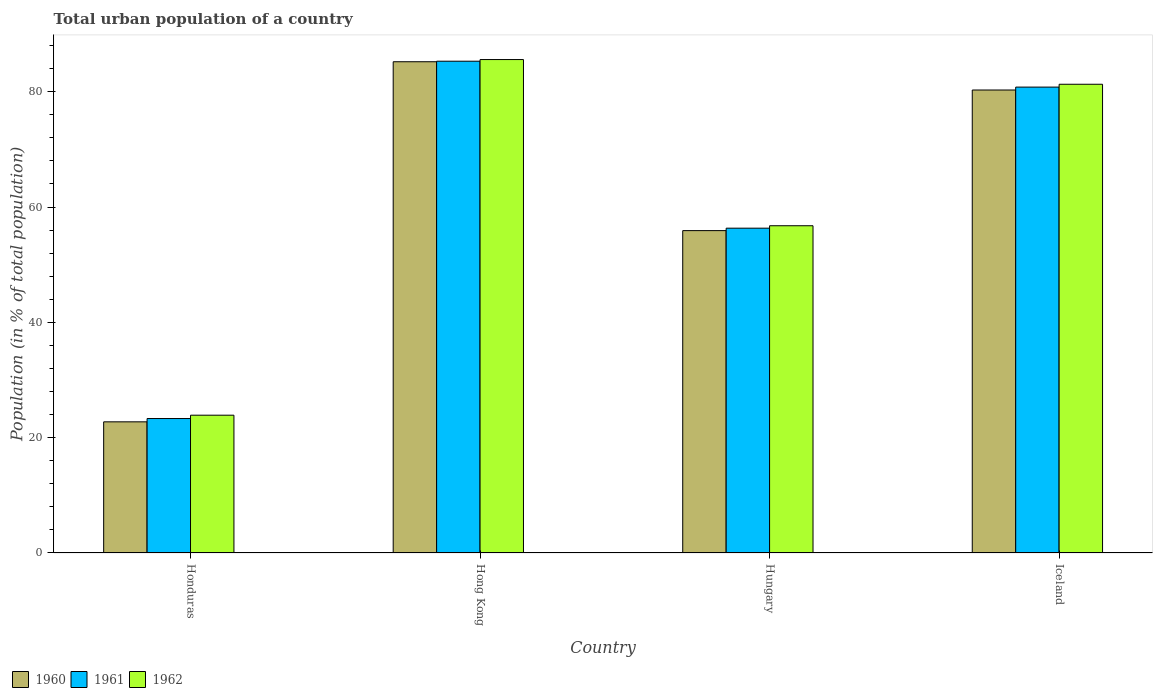Are the number of bars on each tick of the X-axis equal?
Provide a short and direct response. Yes. How many bars are there on the 2nd tick from the right?
Ensure brevity in your answer.  3. What is the label of the 2nd group of bars from the left?
Keep it short and to the point. Hong Kong. What is the urban population in 1961 in Hungary?
Your answer should be very brief. 56.34. Across all countries, what is the maximum urban population in 1961?
Make the answer very short. 85.29. Across all countries, what is the minimum urban population in 1960?
Your answer should be very brief. 22.75. In which country was the urban population in 1960 maximum?
Offer a terse response. Hong Kong. In which country was the urban population in 1962 minimum?
Your response must be concise. Honduras. What is the total urban population in 1960 in the graph?
Provide a short and direct response. 244.16. What is the difference between the urban population in 1962 in Honduras and that in Hong Kong?
Offer a terse response. -61.68. What is the difference between the urban population in 1962 in Hungary and the urban population in 1960 in Hong Kong?
Keep it short and to the point. -28.44. What is the average urban population in 1960 per country?
Keep it short and to the point. 61.04. What is the difference between the urban population of/in 1960 and urban population of/in 1962 in Hong Kong?
Offer a terse response. -0.38. In how many countries, is the urban population in 1962 greater than 36 %?
Your answer should be compact. 3. What is the ratio of the urban population in 1962 in Hong Kong to that in Hungary?
Give a very brief answer. 1.51. Is the urban population in 1962 in Honduras less than that in Hungary?
Your answer should be very brief. Yes. Is the difference between the urban population in 1960 in Honduras and Iceland greater than the difference between the urban population in 1962 in Honduras and Iceland?
Your answer should be very brief. No. What is the difference between the highest and the second highest urban population in 1960?
Your answer should be very brief. -4.9. What is the difference between the highest and the lowest urban population in 1961?
Provide a succinct answer. 61.97. Are the values on the major ticks of Y-axis written in scientific E-notation?
Your response must be concise. No. Where does the legend appear in the graph?
Keep it short and to the point. Bottom left. How many legend labels are there?
Keep it short and to the point. 3. What is the title of the graph?
Your answer should be compact. Total urban population of a country. What is the label or title of the X-axis?
Ensure brevity in your answer.  Country. What is the label or title of the Y-axis?
Ensure brevity in your answer.  Population (in % of total population). What is the Population (in % of total population) of 1960 in Honduras?
Offer a very short reply. 22.75. What is the Population (in % of total population) in 1961 in Honduras?
Ensure brevity in your answer.  23.32. What is the Population (in % of total population) of 1962 in Honduras?
Ensure brevity in your answer.  23.9. What is the Population (in % of total population) of 1960 in Hong Kong?
Your answer should be compact. 85.2. What is the Population (in % of total population) in 1961 in Hong Kong?
Keep it short and to the point. 85.29. What is the Population (in % of total population) of 1962 in Hong Kong?
Offer a terse response. 85.58. What is the Population (in % of total population) in 1960 in Hungary?
Your answer should be compact. 55.91. What is the Population (in % of total population) of 1961 in Hungary?
Keep it short and to the point. 56.34. What is the Population (in % of total population) of 1962 in Hungary?
Offer a terse response. 56.76. What is the Population (in % of total population) in 1960 in Iceland?
Provide a succinct answer. 80.3. What is the Population (in % of total population) in 1961 in Iceland?
Your answer should be very brief. 80.8. What is the Population (in % of total population) in 1962 in Iceland?
Provide a short and direct response. 81.3. Across all countries, what is the maximum Population (in % of total population) in 1960?
Your answer should be compact. 85.2. Across all countries, what is the maximum Population (in % of total population) in 1961?
Provide a short and direct response. 85.29. Across all countries, what is the maximum Population (in % of total population) in 1962?
Keep it short and to the point. 85.58. Across all countries, what is the minimum Population (in % of total population) in 1960?
Provide a succinct answer. 22.75. Across all countries, what is the minimum Population (in % of total population) in 1961?
Your answer should be compact. 23.32. Across all countries, what is the minimum Population (in % of total population) in 1962?
Offer a very short reply. 23.9. What is the total Population (in % of total population) of 1960 in the graph?
Your response must be concise. 244.16. What is the total Population (in % of total population) in 1961 in the graph?
Ensure brevity in your answer.  245.75. What is the total Population (in % of total population) of 1962 in the graph?
Make the answer very short. 247.54. What is the difference between the Population (in % of total population) in 1960 in Honduras and that in Hong Kong?
Give a very brief answer. -62.45. What is the difference between the Population (in % of total population) of 1961 in Honduras and that in Hong Kong?
Your answer should be very brief. -61.98. What is the difference between the Population (in % of total population) of 1962 in Honduras and that in Hong Kong?
Your answer should be compact. -61.68. What is the difference between the Population (in % of total population) of 1960 in Honduras and that in Hungary?
Give a very brief answer. -33.16. What is the difference between the Population (in % of total population) of 1961 in Honduras and that in Hungary?
Offer a terse response. -33.02. What is the difference between the Population (in % of total population) of 1962 in Honduras and that in Hungary?
Ensure brevity in your answer.  -32.86. What is the difference between the Population (in % of total population) of 1960 in Honduras and that in Iceland?
Give a very brief answer. -57.55. What is the difference between the Population (in % of total population) in 1961 in Honduras and that in Iceland?
Your response must be concise. -57.48. What is the difference between the Population (in % of total population) in 1962 in Honduras and that in Iceland?
Ensure brevity in your answer.  -57.4. What is the difference between the Population (in % of total population) of 1960 in Hong Kong and that in Hungary?
Provide a short and direct response. 29.29. What is the difference between the Population (in % of total population) of 1961 in Hong Kong and that in Hungary?
Provide a succinct answer. 28.96. What is the difference between the Population (in % of total population) of 1962 in Hong Kong and that in Hungary?
Offer a very short reply. 28.82. What is the difference between the Population (in % of total population) of 1961 in Hong Kong and that in Iceland?
Give a very brief answer. 4.49. What is the difference between the Population (in % of total population) of 1962 in Hong Kong and that in Iceland?
Your answer should be very brief. 4.29. What is the difference between the Population (in % of total population) in 1960 in Hungary and that in Iceland?
Ensure brevity in your answer.  -24.39. What is the difference between the Population (in % of total population) of 1961 in Hungary and that in Iceland?
Ensure brevity in your answer.  -24.47. What is the difference between the Population (in % of total population) in 1962 in Hungary and that in Iceland?
Keep it short and to the point. -24.54. What is the difference between the Population (in % of total population) in 1960 in Honduras and the Population (in % of total population) in 1961 in Hong Kong?
Give a very brief answer. -62.55. What is the difference between the Population (in % of total population) in 1960 in Honduras and the Population (in % of total population) in 1962 in Hong Kong?
Provide a succinct answer. -62.84. What is the difference between the Population (in % of total population) of 1961 in Honduras and the Population (in % of total population) of 1962 in Hong Kong?
Your answer should be very brief. -62.26. What is the difference between the Population (in % of total population) of 1960 in Honduras and the Population (in % of total population) of 1961 in Hungary?
Make the answer very short. -33.59. What is the difference between the Population (in % of total population) in 1960 in Honduras and the Population (in % of total population) in 1962 in Hungary?
Your answer should be very brief. -34.01. What is the difference between the Population (in % of total population) of 1961 in Honduras and the Population (in % of total population) of 1962 in Hungary?
Offer a very short reply. -33.44. What is the difference between the Population (in % of total population) in 1960 in Honduras and the Population (in % of total population) in 1961 in Iceland?
Make the answer very short. -58.06. What is the difference between the Population (in % of total population) of 1960 in Honduras and the Population (in % of total population) of 1962 in Iceland?
Keep it short and to the point. -58.55. What is the difference between the Population (in % of total population) of 1961 in Honduras and the Population (in % of total population) of 1962 in Iceland?
Keep it short and to the point. -57.98. What is the difference between the Population (in % of total population) in 1960 in Hong Kong and the Population (in % of total population) in 1961 in Hungary?
Give a very brief answer. 28.86. What is the difference between the Population (in % of total population) of 1960 in Hong Kong and the Population (in % of total population) of 1962 in Hungary?
Provide a short and direct response. 28.44. What is the difference between the Population (in % of total population) in 1961 in Hong Kong and the Population (in % of total population) in 1962 in Hungary?
Make the answer very short. 28.54. What is the difference between the Population (in % of total population) in 1960 in Hong Kong and the Population (in % of total population) in 1961 in Iceland?
Make the answer very short. 4.4. What is the difference between the Population (in % of total population) of 1960 in Hong Kong and the Population (in % of total population) of 1962 in Iceland?
Give a very brief answer. 3.9. What is the difference between the Population (in % of total population) of 1961 in Hong Kong and the Population (in % of total population) of 1962 in Iceland?
Your answer should be compact. 4. What is the difference between the Population (in % of total population) of 1960 in Hungary and the Population (in % of total population) of 1961 in Iceland?
Your answer should be compact. -24.89. What is the difference between the Population (in % of total population) of 1960 in Hungary and the Population (in % of total population) of 1962 in Iceland?
Give a very brief answer. -25.39. What is the difference between the Population (in % of total population) of 1961 in Hungary and the Population (in % of total population) of 1962 in Iceland?
Your response must be concise. -24.96. What is the average Population (in % of total population) in 1960 per country?
Provide a succinct answer. 61.04. What is the average Population (in % of total population) in 1961 per country?
Make the answer very short. 61.44. What is the average Population (in % of total population) of 1962 per country?
Give a very brief answer. 61.88. What is the difference between the Population (in % of total population) in 1960 and Population (in % of total population) in 1961 in Honduras?
Your response must be concise. -0.57. What is the difference between the Population (in % of total population) of 1960 and Population (in % of total population) of 1962 in Honduras?
Your answer should be compact. -1.15. What is the difference between the Population (in % of total population) of 1961 and Population (in % of total population) of 1962 in Honduras?
Your response must be concise. -0.58. What is the difference between the Population (in % of total population) in 1960 and Population (in % of total population) in 1961 in Hong Kong?
Your response must be concise. -0.09. What is the difference between the Population (in % of total population) of 1960 and Population (in % of total population) of 1962 in Hong Kong?
Your answer should be compact. -0.38. What is the difference between the Population (in % of total population) of 1961 and Population (in % of total population) of 1962 in Hong Kong?
Your answer should be compact. -0.29. What is the difference between the Population (in % of total population) of 1960 and Population (in % of total population) of 1961 in Hungary?
Provide a short and direct response. -0.42. What is the difference between the Population (in % of total population) of 1960 and Population (in % of total population) of 1962 in Hungary?
Offer a very short reply. -0.85. What is the difference between the Population (in % of total population) of 1961 and Population (in % of total population) of 1962 in Hungary?
Offer a terse response. -0.42. What is the difference between the Population (in % of total population) in 1960 and Population (in % of total population) in 1961 in Iceland?
Keep it short and to the point. -0.5. What is the difference between the Population (in % of total population) in 1960 and Population (in % of total population) in 1962 in Iceland?
Keep it short and to the point. -1. What is the difference between the Population (in % of total population) of 1961 and Population (in % of total population) of 1962 in Iceland?
Provide a succinct answer. -0.49. What is the ratio of the Population (in % of total population) of 1960 in Honduras to that in Hong Kong?
Offer a terse response. 0.27. What is the ratio of the Population (in % of total population) in 1961 in Honduras to that in Hong Kong?
Your answer should be very brief. 0.27. What is the ratio of the Population (in % of total population) of 1962 in Honduras to that in Hong Kong?
Provide a short and direct response. 0.28. What is the ratio of the Population (in % of total population) in 1960 in Honduras to that in Hungary?
Your response must be concise. 0.41. What is the ratio of the Population (in % of total population) in 1961 in Honduras to that in Hungary?
Give a very brief answer. 0.41. What is the ratio of the Population (in % of total population) of 1962 in Honduras to that in Hungary?
Your response must be concise. 0.42. What is the ratio of the Population (in % of total population) of 1960 in Honduras to that in Iceland?
Your answer should be compact. 0.28. What is the ratio of the Population (in % of total population) of 1961 in Honduras to that in Iceland?
Offer a very short reply. 0.29. What is the ratio of the Population (in % of total population) of 1962 in Honduras to that in Iceland?
Ensure brevity in your answer.  0.29. What is the ratio of the Population (in % of total population) in 1960 in Hong Kong to that in Hungary?
Ensure brevity in your answer.  1.52. What is the ratio of the Population (in % of total population) in 1961 in Hong Kong to that in Hungary?
Offer a very short reply. 1.51. What is the ratio of the Population (in % of total population) of 1962 in Hong Kong to that in Hungary?
Give a very brief answer. 1.51. What is the ratio of the Population (in % of total population) in 1960 in Hong Kong to that in Iceland?
Make the answer very short. 1.06. What is the ratio of the Population (in % of total population) of 1961 in Hong Kong to that in Iceland?
Your answer should be very brief. 1.06. What is the ratio of the Population (in % of total population) of 1962 in Hong Kong to that in Iceland?
Give a very brief answer. 1.05. What is the ratio of the Population (in % of total population) of 1960 in Hungary to that in Iceland?
Your response must be concise. 0.7. What is the ratio of the Population (in % of total population) of 1961 in Hungary to that in Iceland?
Offer a very short reply. 0.7. What is the ratio of the Population (in % of total population) of 1962 in Hungary to that in Iceland?
Your response must be concise. 0.7. What is the difference between the highest and the second highest Population (in % of total population) of 1960?
Your response must be concise. 4.9. What is the difference between the highest and the second highest Population (in % of total population) in 1961?
Provide a succinct answer. 4.49. What is the difference between the highest and the second highest Population (in % of total population) in 1962?
Your answer should be very brief. 4.29. What is the difference between the highest and the lowest Population (in % of total population) of 1960?
Provide a succinct answer. 62.45. What is the difference between the highest and the lowest Population (in % of total population) in 1961?
Your response must be concise. 61.98. What is the difference between the highest and the lowest Population (in % of total population) of 1962?
Keep it short and to the point. 61.68. 